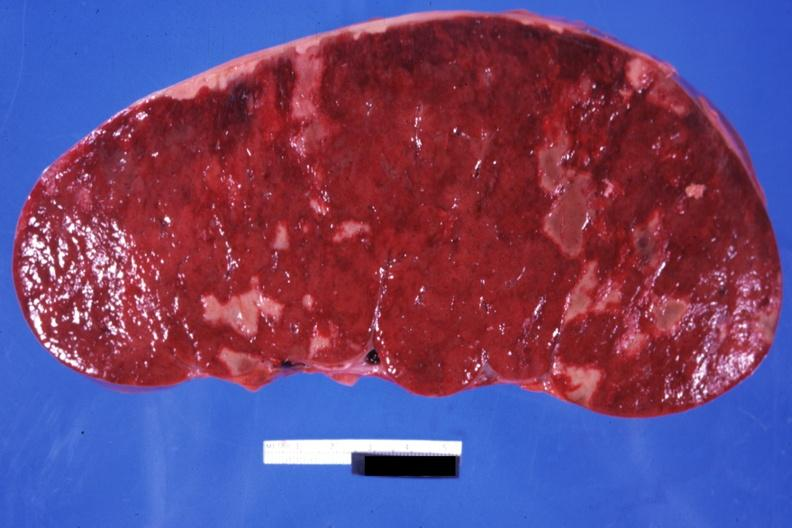does this image show very enlarged spleen with multiple infarcts infiltrative process is easily seen?
Answer the question using a single word or phrase. Yes 